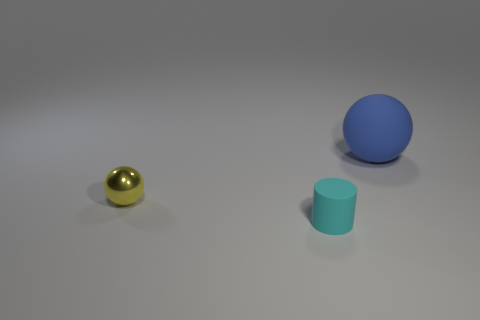What number of other cyan things have the same shape as the tiny metallic thing?
Provide a short and direct response. 0. What number of things are either large blue balls or things that are behind the yellow shiny object?
Offer a terse response. 1. What material is the tiny sphere?
Offer a terse response. Metal. There is a yellow object that is the same shape as the big blue matte object; what is it made of?
Make the answer very short. Metal. The rubber object in front of the rubber thing that is behind the small cyan cylinder is what color?
Your response must be concise. Cyan. How many rubber objects are either blue spheres or big green blocks?
Provide a short and direct response. 1. Is the material of the large blue ball the same as the yellow sphere?
Give a very brief answer. No. The sphere in front of the rubber thing that is behind the yellow sphere is made of what material?
Provide a succinct answer. Metal. What number of large things are either blue things or shiny things?
Provide a short and direct response. 1. The cyan cylinder is what size?
Your answer should be very brief. Small. 